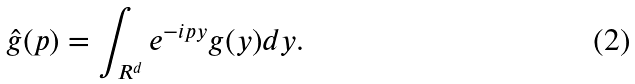Convert formula to latex. <formula><loc_0><loc_0><loc_500><loc_500>\hat { g } ( p ) = \int _ { R ^ { d } } e ^ { - i p y } g ( y ) d y .</formula> 